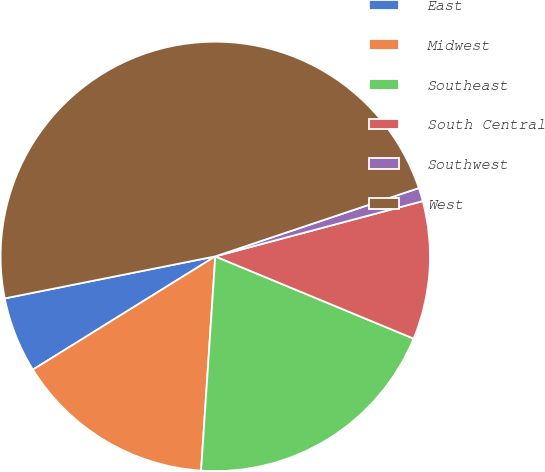<chart> <loc_0><loc_0><loc_500><loc_500><pie_chart><fcel>East<fcel>Midwest<fcel>Southeast<fcel>South Central<fcel>Southwest<fcel>West<nl><fcel>5.71%<fcel>15.1%<fcel>19.8%<fcel>10.4%<fcel>1.01%<fcel>47.98%<nl></chart> 